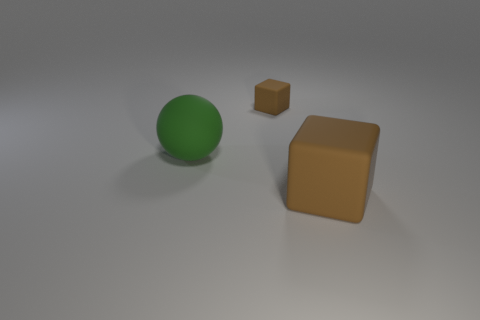Add 2 small brown cubes. How many objects exist? 5 Subtract all blocks. How many objects are left? 1 Add 3 big brown blocks. How many big brown blocks are left? 4 Add 1 small cyan matte blocks. How many small cyan matte blocks exist? 1 Subtract 0 blue spheres. How many objects are left? 3 Subtract all big green things. Subtract all tiny red matte blocks. How many objects are left? 2 